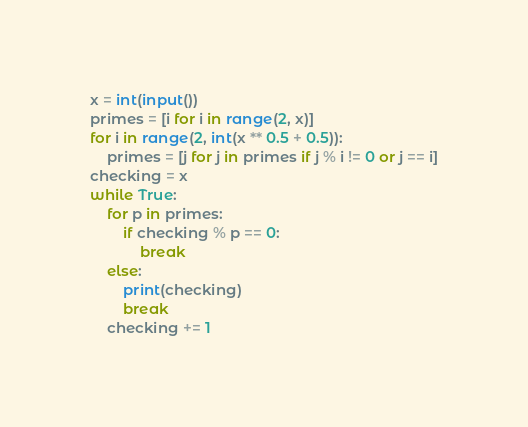<code> <loc_0><loc_0><loc_500><loc_500><_Python_>x = int(input())
primes = [i for i in range(2, x)]
for i in range(2, int(x ** 0.5 + 0.5)):
    primes = [j for j in primes if j % i != 0 or j == i]
checking = x
while True:
    for p in primes:
        if checking % p == 0:
            break
    else:
        print(checking)
        break
    checking += 1
</code> 